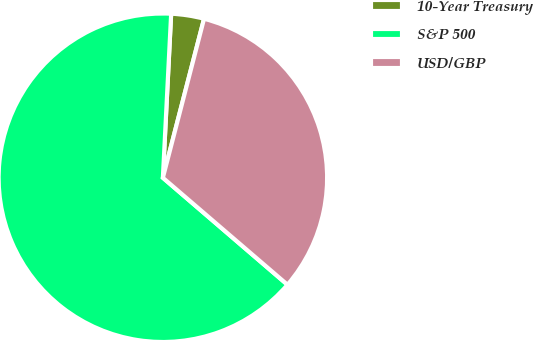<chart> <loc_0><loc_0><loc_500><loc_500><pie_chart><fcel>10-Year Treasury<fcel>S&P 500<fcel>USD/GBP<nl><fcel>3.23%<fcel>64.52%<fcel>32.26%<nl></chart> 